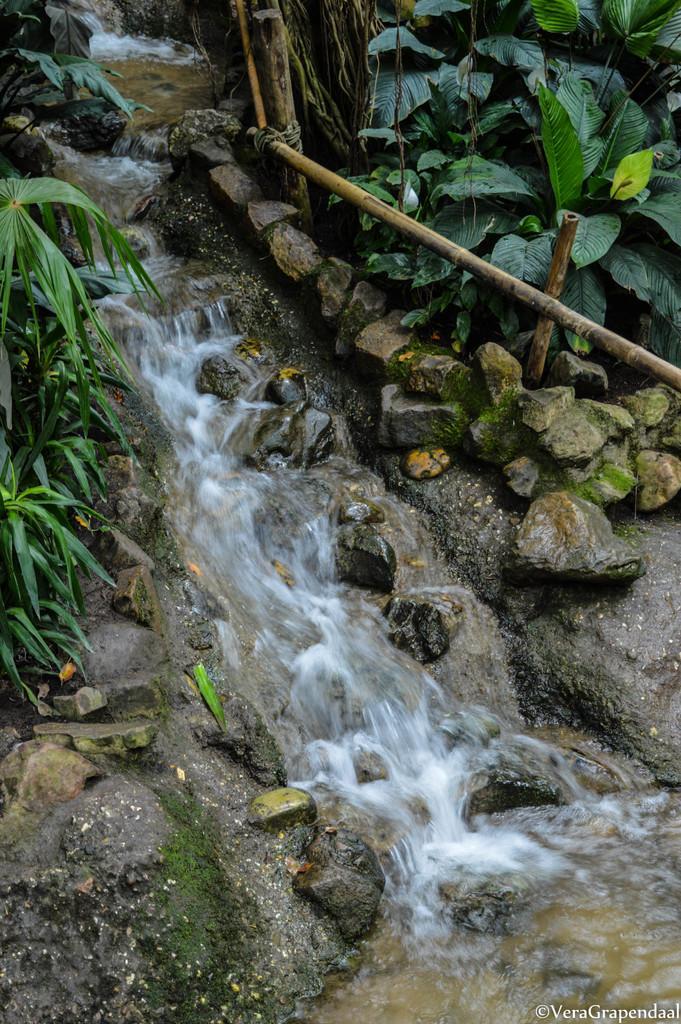Please provide a concise description of this image. In this picture we can see a waterfall, rocks and a fence. On the left and right side of the image, there are plants. In the bottom right corner of the image, there is a watermark. 